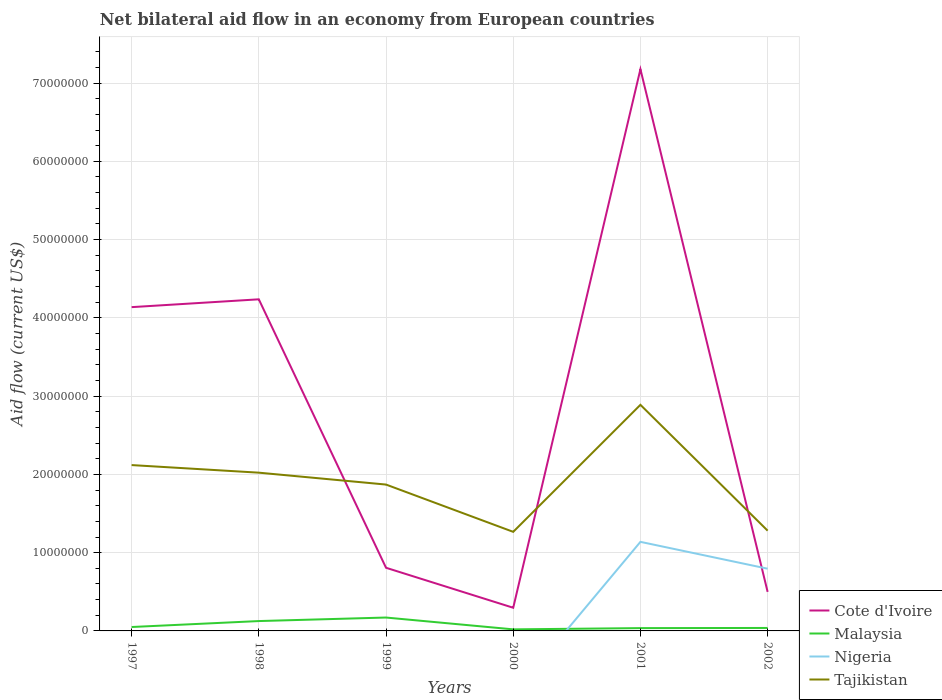Is the number of lines equal to the number of legend labels?
Keep it short and to the point. No. Across all years, what is the maximum net bilateral aid flow in Tajikistan?
Your answer should be compact. 1.27e+07. What is the total net bilateral aid flow in Cote d'Ivoire in the graph?
Provide a succinct answer. -6.88e+07. What is the difference between the highest and the second highest net bilateral aid flow in Malaysia?
Provide a succinct answer. 1.51e+06. How many lines are there?
Your response must be concise. 4. Does the graph contain grids?
Offer a very short reply. Yes. Where does the legend appear in the graph?
Keep it short and to the point. Bottom right. How are the legend labels stacked?
Your response must be concise. Vertical. What is the title of the graph?
Your answer should be very brief. Net bilateral aid flow in an economy from European countries. Does "Guyana" appear as one of the legend labels in the graph?
Provide a succinct answer. No. What is the label or title of the X-axis?
Your answer should be very brief. Years. What is the Aid flow (current US$) in Cote d'Ivoire in 1997?
Your answer should be compact. 4.14e+07. What is the Aid flow (current US$) of Malaysia in 1997?
Make the answer very short. 5.00e+05. What is the Aid flow (current US$) in Tajikistan in 1997?
Your answer should be very brief. 2.12e+07. What is the Aid flow (current US$) in Cote d'Ivoire in 1998?
Give a very brief answer. 4.24e+07. What is the Aid flow (current US$) in Malaysia in 1998?
Make the answer very short. 1.26e+06. What is the Aid flow (current US$) in Nigeria in 1998?
Your response must be concise. 0. What is the Aid flow (current US$) in Tajikistan in 1998?
Offer a very short reply. 2.02e+07. What is the Aid flow (current US$) in Cote d'Ivoire in 1999?
Offer a very short reply. 8.07e+06. What is the Aid flow (current US$) in Malaysia in 1999?
Give a very brief answer. 1.71e+06. What is the Aid flow (current US$) of Nigeria in 1999?
Provide a short and direct response. 0. What is the Aid flow (current US$) of Tajikistan in 1999?
Provide a short and direct response. 1.87e+07. What is the Aid flow (current US$) of Cote d'Ivoire in 2000?
Give a very brief answer. 2.96e+06. What is the Aid flow (current US$) in Nigeria in 2000?
Give a very brief answer. 0. What is the Aid flow (current US$) of Tajikistan in 2000?
Keep it short and to the point. 1.27e+07. What is the Aid flow (current US$) in Cote d'Ivoire in 2001?
Your answer should be compact. 7.18e+07. What is the Aid flow (current US$) in Malaysia in 2001?
Provide a succinct answer. 3.60e+05. What is the Aid flow (current US$) in Nigeria in 2001?
Keep it short and to the point. 1.14e+07. What is the Aid flow (current US$) in Tajikistan in 2001?
Offer a very short reply. 2.89e+07. What is the Aid flow (current US$) of Cote d'Ivoire in 2002?
Give a very brief answer. 4.99e+06. What is the Aid flow (current US$) of Nigeria in 2002?
Make the answer very short. 7.95e+06. What is the Aid flow (current US$) of Tajikistan in 2002?
Your response must be concise. 1.28e+07. Across all years, what is the maximum Aid flow (current US$) in Cote d'Ivoire?
Keep it short and to the point. 7.18e+07. Across all years, what is the maximum Aid flow (current US$) in Malaysia?
Provide a short and direct response. 1.71e+06. Across all years, what is the maximum Aid flow (current US$) in Nigeria?
Make the answer very short. 1.14e+07. Across all years, what is the maximum Aid flow (current US$) in Tajikistan?
Make the answer very short. 2.89e+07. Across all years, what is the minimum Aid flow (current US$) of Cote d'Ivoire?
Your answer should be very brief. 2.96e+06. Across all years, what is the minimum Aid flow (current US$) of Malaysia?
Your response must be concise. 2.00e+05. Across all years, what is the minimum Aid flow (current US$) in Tajikistan?
Your response must be concise. 1.27e+07. What is the total Aid flow (current US$) in Cote d'Ivoire in the graph?
Your answer should be very brief. 1.72e+08. What is the total Aid flow (current US$) in Malaysia in the graph?
Keep it short and to the point. 4.41e+06. What is the total Aid flow (current US$) of Nigeria in the graph?
Offer a terse response. 1.93e+07. What is the total Aid flow (current US$) of Tajikistan in the graph?
Provide a short and direct response. 1.14e+08. What is the difference between the Aid flow (current US$) of Cote d'Ivoire in 1997 and that in 1998?
Give a very brief answer. -1.00e+06. What is the difference between the Aid flow (current US$) in Malaysia in 1997 and that in 1998?
Give a very brief answer. -7.60e+05. What is the difference between the Aid flow (current US$) of Tajikistan in 1997 and that in 1998?
Offer a terse response. 9.70e+05. What is the difference between the Aid flow (current US$) of Cote d'Ivoire in 1997 and that in 1999?
Make the answer very short. 3.33e+07. What is the difference between the Aid flow (current US$) in Malaysia in 1997 and that in 1999?
Your answer should be very brief. -1.21e+06. What is the difference between the Aid flow (current US$) in Tajikistan in 1997 and that in 1999?
Your answer should be compact. 2.49e+06. What is the difference between the Aid flow (current US$) in Cote d'Ivoire in 1997 and that in 2000?
Provide a short and direct response. 3.84e+07. What is the difference between the Aid flow (current US$) in Tajikistan in 1997 and that in 2000?
Offer a very short reply. 8.53e+06. What is the difference between the Aid flow (current US$) of Cote d'Ivoire in 1997 and that in 2001?
Keep it short and to the point. -3.04e+07. What is the difference between the Aid flow (current US$) in Tajikistan in 1997 and that in 2001?
Provide a succinct answer. -7.70e+06. What is the difference between the Aid flow (current US$) of Cote d'Ivoire in 1997 and that in 2002?
Make the answer very short. 3.64e+07. What is the difference between the Aid flow (current US$) of Malaysia in 1997 and that in 2002?
Your answer should be compact. 1.20e+05. What is the difference between the Aid flow (current US$) in Tajikistan in 1997 and that in 2002?
Give a very brief answer. 8.38e+06. What is the difference between the Aid flow (current US$) of Cote d'Ivoire in 1998 and that in 1999?
Your answer should be very brief. 3.43e+07. What is the difference between the Aid flow (current US$) in Malaysia in 1998 and that in 1999?
Ensure brevity in your answer.  -4.50e+05. What is the difference between the Aid flow (current US$) of Tajikistan in 1998 and that in 1999?
Provide a succinct answer. 1.52e+06. What is the difference between the Aid flow (current US$) of Cote d'Ivoire in 1998 and that in 2000?
Your answer should be compact. 3.94e+07. What is the difference between the Aid flow (current US$) in Malaysia in 1998 and that in 2000?
Your answer should be compact. 1.06e+06. What is the difference between the Aid flow (current US$) of Tajikistan in 1998 and that in 2000?
Provide a short and direct response. 7.56e+06. What is the difference between the Aid flow (current US$) in Cote d'Ivoire in 1998 and that in 2001?
Ensure brevity in your answer.  -2.94e+07. What is the difference between the Aid flow (current US$) in Malaysia in 1998 and that in 2001?
Your answer should be very brief. 9.00e+05. What is the difference between the Aid flow (current US$) in Tajikistan in 1998 and that in 2001?
Your answer should be compact. -8.67e+06. What is the difference between the Aid flow (current US$) in Cote d'Ivoire in 1998 and that in 2002?
Make the answer very short. 3.74e+07. What is the difference between the Aid flow (current US$) in Malaysia in 1998 and that in 2002?
Your answer should be compact. 8.80e+05. What is the difference between the Aid flow (current US$) in Tajikistan in 1998 and that in 2002?
Provide a succinct answer. 7.41e+06. What is the difference between the Aid flow (current US$) in Cote d'Ivoire in 1999 and that in 2000?
Your response must be concise. 5.11e+06. What is the difference between the Aid flow (current US$) in Malaysia in 1999 and that in 2000?
Your answer should be very brief. 1.51e+06. What is the difference between the Aid flow (current US$) of Tajikistan in 1999 and that in 2000?
Ensure brevity in your answer.  6.04e+06. What is the difference between the Aid flow (current US$) in Cote d'Ivoire in 1999 and that in 2001?
Your answer should be compact. -6.37e+07. What is the difference between the Aid flow (current US$) in Malaysia in 1999 and that in 2001?
Offer a very short reply. 1.35e+06. What is the difference between the Aid flow (current US$) of Tajikistan in 1999 and that in 2001?
Offer a terse response. -1.02e+07. What is the difference between the Aid flow (current US$) of Cote d'Ivoire in 1999 and that in 2002?
Keep it short and to the point. 3.08e+06. What is the difference between the Aid flow (current US$) of Malaysia in 1999 and that in 2002?
Keep it short and to the point. 1.33e+06. What is the difference between the Aid flow (current US$) of Tajikistan in 1999 and that in 2002?
Make the answer very short. 5.89e+06. What is the difference between the Aid flow (current US$) of Cote d'Ivoire in 2000 and that in 2001?
Offer a very short reply. -6.88e+07. What is the difference between the Aid flow (current US$) in Malaysia in 2000 and that in 2001?
Ensure brevity in your answer.  -1.60e+05. What is the difference between the Aid flow (current US$) in Tajikistan in 2000 and that in 2001?
Your answer should be compact. -1.62e+07. What is the difference between the Aid flow (current US$) of Cote d'Ivoire in 2000 and that in 2002?
Your answer should be compact. -2.03e+06. What is the difference between the Aid flow (current US$) of Tajikistan in 2000 and that in 2002?
Ensure brevity in your answer.  -1.50e+05. What is the difference between the Aid flow (current US$) of Cote d'Ivoire in 2001 and that in 2002?
Keep it short and to the point. 6.68e+07. What is the difference between the Aid flow (current US$) of Nigeria in 2001 and that in 2002?
Offer a terse response. 3.43e+06. What is the difference between the Aid flow (current US$) in Tajikistan in 2001 and that in 2002?
Your answer should be compact. 1.61e+07. What is the difference between the Aid flow (current US$) of Cote d'Ivoire in 1997 and the Aid flow (current US$) of Malaysia in 1998?
Offer a very short reply. 4.01e+07. What is the difference between the Aid flow (current US$) in Cote d'Ivoire in 1997 and the Aid flow (current US$) in Tajikistan in 1998?
Make the answer very short. 2.12e+07. What is the difference between the Aid flow (current US$) of Malaysia in 1997 and the Aid flow (current US$) of Tajikistan in 1998?
Your answer should be compact. -1.97e+07. What is the difference between the Aid flow (current US$) in Cote d'Ivoire in 1997 and the Aid flow (current US$) in Malaysia in 1999?
Offer a terse response. 3.97e+07. What is the difference between the Aid flow (current US$) of Cote d'Ivoire in 1997 and the Aid flow (current US$) of Tajikistan in 1999?
Offer a very short reply. 2.27e+07. What is the difference between the Aid flow (current US$) in Malaysia in 1997 and the Aid flow (current US$) in Tajikistan in 1999?
Your answer should be compact. -1.82e+07. What is the difference between the Aid flow (current US$) of Cote d'Ivoire in 1997 and the Aid flow (current US$) of Malaysia in 2000?
Make the answer very short. 4.12e+07. What is the difference between the Aid flow (current US$) of Cote d'Ivoire in 1997 and the Aid flow (current US$) of Tajikistan in 2000?
Provide a short and direct response. 2.87e+07. What is the difference between the Aid flow (current US$) in Malaysia in 1997 and the Aid flow (current US$) in Tajikistan in 2000?
Keep it short and to the point. -1.22e+07. What is the difference between the Aid flow (current US$) in Cote d'Ivoire in 1997 and the Aid flow (current US$) in Malaysia in 2001?
Ensure brevity in your answer.  4.10e+07. What is the difference between the Aid flow (current US$) in Cote d'Ivoire in 1997 and the Aid flow (current US$) in Nigeria in 2001?
Ensure brevity in your answer.  3.00e+07. What is the difference between the Aid flow (current US$) of Cote d'Ivoire in 1997 and the Aid flow (current US$) of Tajikistan in 2001?
Your response must be concise. 1.25e+07. What is the difference between the Aid flow (current US$) in Malaysia in 1997 and the Aid flow (current US$) in Nigeria in 2001?
Your answer should be very brief. -1.09e+07. What is the difference between the Aid flow (current US$) of Malaysia in 1997 and the Aid flow (current US$) of Tajikistan in 2001?
Give a very brief answer. -2.84e+07. What is the difference between the Aid flow (current US$) in Cote d'Ivoire in 1997 and the Aid flow (current US$) in Malaysia in 2002?
Your answer should be very brief. 4.10e+07. What is the difference between the Aid flow (current US$) in Cote d'Ivoire in 1997 and the Aid flow (current US$) in Nigeria in 2002?
Your response must be concise. 3.34e+07. What is the difference between the Aid flow (current US$) of Cote d'Ivoire in 1997 and the Aid flow (current US$) of Tajikistan in 2002?
Keep it short and to the point. 2.86e+07. What is the difference between the Aid flow (current US$) of Malaysia in 1997 and the Aid flow (current US$) of Nigeria in 2002?
Give a very brief answer. -7.45e+06. What is the difference between the Aid flow (current US$) in Malaysia in 1997 and the Aid flow (current US$) in Tajikistan in 2002?
Provide a short and direct response. -1.23e+07. What is the difference between the Aid flow (current US$) of Cote d'Ivoire in 1998 and the Aid flow (current US$) of Malaysia in 1999?
Provide a succinct answer. 4.07e+07. What is the difference between the Aid flow (current US$) of Cote d'Ivoire in 1998 and the Aid flow (current US$) of Tajikistan in 1999?
Your answer should be very brief. 2.37e+07. What is the difference between the Aid flow (current US$) of Malaysia in 1998 and the Aid flow (current US$) of Tajikistan in 1999?
Give a very brief answer. -1.74e+07. What is the difference between the Aid flow (current US$) of Cote d'Ivoire in 1998 and the Aid flow (current US$) of Malaysia in 2000?
Give a very brief answer. 4.22e+07. What is the difference between the Aid flow (current US$) of Cote d'Ivoire in 1998 and the Aid flow (current US$) of Tajikistan in 2000?
Make the answer very short. 2.97e+07. What is the difference between the Aid flow (current US$) in Malaysia in 1998 and the Aid flow (current US$) in Tajikistan in 2000?
Keep it short and to the point. -1.14e+07. What is the difference between the Aid flow (current US$) of Cote d'Ivoire in 1998 and the Aid flow (current US$) of Malaysia in 2001?
Provide a short and direct response. 4.20e+07. What is the difference between the Aid flow (current US$) in Cote d'Ivoire in 1998 and the Aid flow (current US$) in Nigeria in 2001?
Your response must be concise. 3.10e+07. What is the difference between the Aid flow (current US$) in Cote d'Ivoire in 1998 and the Aid flow (current US$) in Tajikistan in 2001?
Provide a short and direct response. 1.35e+07. What is the difference between the Aid flow (current US$) in Malaysia in 1998 and the Aid flow (current US$) in Nigeria in 2001?
Offer a very short reply. -1.01e+07. What is the difference between the Aid flow (current US$) of Malaysia in 1998 and the Aid flow (current US$) of Tajikistan in 2001?
Provide a succinct answer. -2.76e+07. What is the difference between the Aid flow (current US$) in Cote d'Ivoire in 1998 and the Aid flow (current US$) in Malaysia in 2002?
Give a very brief answer. 4.20e+07. What is the difference between the Aid flow (current US$) in Cote d'Ivoire in 1998 and the Aid flow (current US$) in Nigeria in 2002?
Give a very brief answer. 3.44e+07. What is the difference between the Aid flow (current US$) of Cote d'Ivoire in 1998 and the Aid flow (current US$) of Tajikistan in 2002?
Give a very brief answer. 2.96e+07. What is the difference between the Aid flow (current US$) of Malaysia in 1998 and the Aid flow (current US$) of Nigeria in 2002?
Ensure brevity in your answer.  -6.69e+06. What is the difference between the Aid flow (current US$) of Malaysia in 1998 and the Aid flow (current US$) of Tajikistan in 2002?
Keep it short and to the point. -1.16e+07. What is the difference between the Aid flow (current US$) in Cote d'Ivoire in 1999 and the Aid flow (current US$) in Malaysia in 2000?
Make the answer very short. 7.87e+06. What is the difference between the Aid flow (current US$) of Cote d'Ivoire in 1999 and the Aid flow (current US$) of Tajikistan in 2000?
Your answer should be very brief. -4.59e+06. What is the difference between the Aid flow (current US$) of Malaysia in 1999 and the Aid flow (current US$) of Tajikistan in 2000?
Provide a short and direct response. -1.10e+07. What is the difference between the Aid flow (current US$) of Cote d'Ivoire in 1999 and the Aid flow (current US$) of Malaysia in 2001?
Give a very brief answer. 7.71e+06. What is the difference between the Aid flow (current US$) of Cote d'Ivoire in 1999 and the Aid flow (current US$) of Nigeria in 2001?
Provide a succinct answer. -3.31e+06. What is the difference between the Aid flow (current US$) of Cote d'Ivoire in 1999 and the Aid flow (current US$) of Tajikistan in 2001?
Make the answer very short. -2.08e+07. What is the difference between the Aid flow (current US$) in Malaysia in 1999 and the Aid flow (current US$) in Nigeria in 2001?
Offer a terse response. -9.67e+06. What is the difference between the Aid flow (current US$) of Malaysia in 1999 and the Aid flow (current US$) of Tajikistan in 2001?
Make the answer very short. -2.72e+07. What is the difference between the Aid flow (current US$) of Cote d'Ivoire in 1999 and the Aid flow (current US$) of Malaysia in 2002?
Your answer should be very brief. 7.69e+06. What is the difference between the Aid flow (current US$) of Cote d'Ivoire in 1999 and the Aid flow (current US$) of Tajikistan in 2002?
Provide a succinct answer. -4.74e+06. What is the difference between the Aid flow (current US$) in Malaysia in 1999 and the Aid flow (current US$) in Nigeria in 2002?
Your answer should be very brief. -6.24e+06. What is the difference between the Aid flow (current US$) in Malaysia in 1999 and the Aid flow (current US$) in Tajikistan in 2002?
Give a very brief answer. -1.11e+07. What is the difference between the Aid flow (current US$) in Cote d'Ivoire in 2000 and the Aid flow (current US$) in Malaysia in 2001?
Your answer should be compact. 2.60e+06. What is the difference between the Aid flow (current US$) of Cote d'Ivoire in 2000 and the Aid flow (current US$) of Nigeria in 2001?
Your response must be concise. -8.42e+06. What is the difference between the Aid flow (current US$) in Cote d'Ivoire in 2000 and the Aid flow (current US$) in Tajikistan in 2001?
Offer a very short reply. -2.59e+07. What is the difference between the Aid flow (current US$) of Malaysia in 2000 and the Aid flow (current US$) of Nigeria in 2001?
Offer a terse response. -1.12e+07. What is the difference between the Aid flow (current US$) in Malaysia in 2000 and the Aid flow (current US$) in Tajikistan in 2001?
Your answer should be compact. -2.87e+07. What is the difference between the Aid flow (current US$) in Cote d'Ivoire in 2000 and the Aid flow (current US$) in Malaysia in 2002?
Provide a short and direct response. 2.58e+06. What is the difference between the Aid flow (current US$) of Cote d'Ivoire in 2000 and the Aid flow (current US$) of Nigeria in 2002?
Provide a short and direct response. -4.99e+06. What is the difference between the Aid flow (current US$) of Cote d'Ivoire in 2000 and the Aid flow (current US$) of Tajikistan in 2002?
Provide a short and direct response. -9.85e+06. What is the difference between the Aid flow (current US$) of Malaysia in 2000 and the Aid flow (current US$) of Nigeria in 2002?
Offer a very short reply. -7.75e+06. What is the difference between the Aid flow (current US$) in Malaysia in 2000 and the Aid flow (current US$) in Tajikistan in 2002?
Provide a short and direct response. -1.26e+07. What is the difference between the Aid flow (current US$) in Cote d'Ivoire in 2001 and the Aid flow (current US$) in Malaysia in 2002?
Provide a short and direct response. 7.14e+07. What is the difference between the Aid flow (current US$) of Cote d'Ivoire in 2001 and the Aid flow (current US$) of Nigeria in 2002?
Your answer should be very brief. 6.38e+07. What is the difference between the Aid flow (current US$) of Cote d'Ivoire in 2001 and the Aid flow (current US$) of Tajikistan in 2002?
Your response must be concise. 5.90e+07. What is the difference between the Aid flow (current US$) of Malaysia in 2001 and the Aid flow (current US$) of Nigeria in 2002?
Ensure brevity in your answer.  -7.59e+06. What is the difference between the Aid flow (current US$) of Malaysia in 2001 and the Aid flow (current US$) of Tajikistan in 2002?
Your answer should be compact. -1.24e+07. What is the difference between the Aid flow (current US$) of Nigeria in 2001 and the Aid flow (current US$) of Tajikistan in 2002?
Keep it short and to the point. -1.43e+06. What is the average Aid flow (current US$) in Cote d'Ivoire per year?
Make the answer very short. 2.86e+07. What is the average Aid flow (current US$) in Malaysia per year?
Keep it short and to the point. 7.35e+05. What is the average Aid flow (current US$) in Nigeria per year?
Give a very brief answer. 3.22e+06. What is the average Aid flow (current US$) in Tajikistan per year?
Offer a terse response. 1.91e+07. In the year 1997, what is the difference between the Aid flow (current US$) in Cote d'Ivoire and Aid flow (current US$) in Malaysia?
Provide a succinct answer. 4.09e+07. In the year 1997, what is the difference between the Aid flow (current US$) in Cote d'Ivoire and Aid flow (current US$) in Tajikistan?
Give a very brief answer. 2.02e+07. In the year 1997, what is the difference between the Aid flow (current US$) of Malaysia and Aid flow (current US$) of Tajikistan?
Provide a succinct answer. -2.07e+07. In the year 1998, what is the difference between the Aid flow (current US$) of Cote d'Ivoire and Aid flow (current US$) of Malaysia?
Ensure brevity in your answer.  4.11e+07. In the year 1998, what is the difference between the Aid flow (current US$) in Cote d'Ivoire and Aid flow (current US$) in Tajikistan?
Offer a very short reply. 2.22e+07. In the year 1998, what is the difference between the Aid flow (current US$) in Malaysia and Aid flow (current US$) in Tajikistan?
Your response must be concise. -1.90e+07. In the year 1999, what is the difference between the Aid flow (current US$) in Cote d'Ivoire and Aid flow (current US$) in Malaysia?
Ensure brevity in your answer.  6.36e+06. In the year 1999, what is the difference between the Aid flow (current US$) of Cote d'Ivoire and Aid flow (current US$) of Tajikistan?
Provide a short and direct response. -1.06e+07. In the year 1999, what is the difference between the Aid flow (current US$) in Malaysia and Aid flow (current US$) in Tajikistan?
Give a very brief answer. -1.70e+07. In the year 2000, what is the difference between the Aid flow (current US$) of Cote d'Ivoire and Aid flow (current US$) of Malaysia?
Keep it short and to the point. 2.76e+06. In the year 2000, what is the difference between the Aid flow (current US$) of Cote d'Ivoire and Aid flow (current US$) of Tajikistan?
Ensure brevity in your answer.  -9.70e+06. In the year 2000, what is the difference between the Aid flow (current US$) in Malaysia and Aid flow (current US$) in Tajikistan?
Your answer should be very brief. -1.25e+07. In the year 2001, what is the difference between the Aid flow (current US$) of Cote d'Ivoire and Aid flow (current US$) of Malaysia?
Provide a succinct answer. 7.14e+07. In the year 2001, what is the difference between the Aid flow (current US$) in Cote d'Ivoire and Aid flow (current US$) in Nigeria?
Offer a very short reply. 6.04e+07. In the year 2001, what is the difference between the Aid flow (current US$) of Cote d'Ivoire and Aid flow (current US$) of Tajikistan?
Your answer should be compact. 4.29e+07. In the year 2001, what is the difference between the Aid flow (current US$) of Malaysia and Aid flow (current US$) of Nigeria?
Make the answer very short. -1.10e+07. In the year 2001, what is the difference between the Aid flow (current US$) of Malaysia and Aid flow (current US$) of Tajikistan?
Your answer should be very brief. -2.85e+07. In the year 2001, what is the difference between the Aid flow (current US$) in Nigeria and Aid flow (current US$) in Tajikistan?
Make the answer very short. -1.75e+07. In the year 2002, what is the difference between the Aid flow (current US$) of Cote d'Ivoire and Aid flow (current US$) of Malaysia?
Keep it short and to the point. 4.61e+06. In the year 2002, what is the difference between the Aid flow (current US$) of Cote d'Ivoire and Aid flow (current US$) of Nigeria?
Your response must be concise. -2.96e+06. In the year 2002, what is the difference between the Aid flow (current US$) of Cote d'Ivoire and Aid flow (current US$) of Tajikistan?
Keep it short and to the point. -7.82e+06. In the year 2002, what is the difference between the Aid flow (current US$) of Malaysia and Aid flow (current US$) of Nigeria?
Provide a succinct answer. -7.57e+06. In the year 2002, what is the difference between the Aid flow (current US$) in Malaysia and Aid flow (current US$) in Tajikistan?
Make the answer very short. -1.24e+07. In the year 2002, what is the difference between the Aid flow (current US$) of Nigeria and Aid flow (current US$) of Tajikistan?
Your response must be concise. -4.86e+06. What is the ratio of the Aid flow (current US$) of Cote d'Ivoire in 1997 to that in 1998?
Offer a very short reply. 0.98. What is the ratio of the Aid flow (current US$) of Malaysia in 1997 to that in 1998?
Ensure brevity in your answer.  0.4. What is the ratio of the Aid flow (current US$) in Tajikistan in 1997 to that in 1998?
Offer a very short reply. 1.05. What is the ratio of the Aid flow (current US$) in Cote d'Ivoire in 1997 to that in 1999?
Make the answer very short. 5.13. What is the ratio of the Aid flow (current US$) in Malaysia in 1997 to that in 1999?
Your answer should be very brief. 0.29. What is the ratio of the Aid flow (current US$) in Tajikistan in 1997 to that in 1999?
Provide a short and direct response. 1.13. What is the ratio of the Aid flow (current US$) of Cote d'Ivoire in 1997 to that in 2000?
Offer a terse response. 13.98. What is the ratio of the Aid flow (current US$) of Tajikistan in 1997 to that in 2000?
Keep it short and to the point. 1.67. What is the ratio of the Aid flow (current US$) of Cote d'Ivoire in 1997 to that in 2001?
Make the answer very short. 0.58. What is the ratio of the Aid flow (current US$) in Malaysia in 1997 to that in 2001?
Provide a short and direct response. 1.39. What is the ratio of the Aid flow (current US$) in Tajikistan in 1997 to that in 2001?
Your answer should be compact. 0.73. What is the ratio of the Aid flow (current US$) of Cote d'Ivoire in 1997 to that in 2002?
Your response must be concise. 8.29. What is the ratio of the Aid flow (current US$) in Malaysia in 1997 to that in 2002?
Give a very brief answer. 1.32. What is the ratio of the Aid flow (current US$) in Tajikistan in 1997 to that in 2002?
Give a very brief answer. 1.65. What is the ratio of the Aid flow (current US$) of Cote d'Ivoire in 1998 to that in 1999?
Your answer should be very brief. 5.25. What is the ratio of the Aid flow (current US$) in Malaysia in 1998 to that in 1999?
Your answer should be compact. 0.74. What is the ratio of the Aid flow (current US$) of Tajikistan in 1998 to that in 1999?
Offer a terse response. 1.08. What is the ratio of the Aid flow (current US$) in Cote d'Ivoire in 1998 to that in 2000?
Keep it short and to the point. 14.31. What is the ratio of the Aid flow (current US$) of Tajikistan in 1998 to that in 2000?
Offer a terse response. 1.6. What is the ratio of the Aid flow (current US$) of Cote d'Ivoire in 1998 to that in 2001?
Your response must be concise. 0.59. What is the ratio of the Aid flow (current US$) of Malaysia in 1998 to that in 2001?
Your answer should be compact. 3.5. What is the ratio of the Aid flow (current US$) in Tajikistan in 1998 to that in 2001?
Your response must be concise. 0.7. What is the ratio of the Aid flow (current US$) of Cote d'Ivoire in 1998 to that in 2002?
Ensure brevity in your answer.  8.49. What is the ratio of the Aid flow (current US$) of Malaysia in 1998 to that in 2002?
Offer a very short reply. 3.32. What is the ratio of the Aid flow (current US$) in Tajikistan in 1998 to that in 2002?
Provide a short and direct response. 1.58. What is the ratio of the Aid flow (current US$) of Cote d'Ivoire in 1999 to that in 2000?
Make the answer very short. 2.73. What is the ratio of the Aid flow (current US$) of Malaysia in 1999 to that in 2000?
Provide a short and direct response. 8.55. What is the ratio of the Aid flow (current US$) of Tajikistan in 1999 to that in 2000?
Offer a terse response. 1.48. What is the ratio of the Aid flow (current US$) of Cote d'Ivoire in 1999 to that in 2001?
Keep it short and to the point. 0.11. What is the ratio of the Aid flow (current US$) of Malaysia in 1999 to that in 2001?
Keep it short and to the point. 4.75. What is the ratio of the Aid flow (current US$) of Tajikistan in 1999 to that in 2001?
Ensure brevity in your answer.  0.65. What is the ratio of the Aid flow (current US$) of Cote d'Ivoire in 1999 to that in 2002?
Keep it short and to the point. 1.62. What is the ratio of the Aid flow (current US$) of Tajikistan in 1999 to that in 2002?
Your answer should be very brief. 1.46. What is the ratio of the Aid flow (current US$) of Cote d'Ivoire in 2000 to that in 2001?
Make the answer very short. 0.04. What is the ratio of the Aid flow (current US$) of Malaysia in 2000 to that in 2001?
Make the answer very short. 0.56. What is the ratio of the Aid flow (current US$) of Tajikistan in 2000 to that in 2001?
Your answer should be compact. 0.44. What is the ratio of the Aid flow (current US$) in Cote d'Ivoire in 2000 to that in 2002?
Your answer should be compact. 0.59. What is the ratio of the Aid flow (current US$) of Malaysia in 2000 to that in 2002?
Your response must be concise. 0.53. What is the ratio of the Aid flow (current US$) in Tajikistan in 2000 to that in 2002?
Provide a short and direct response. 0.99. What is the ratio of the Aid flow (current US$) of Cote d'Ivoire in 2001 to that in 2002?
Provide a succinct answer. 14.38. What is the ratio of the Aid flow (current US$) in Malaysia in 2001 to that in 2002?
Give a very brief answer. 0.95. What is the ratio of the Aid flow (current US$) of Nigeria in 2001 to that in 2002?
Provide a succinct answer. 1.43. What is the ratio of the Aid flow (current US$) of Tajikistan in 2001 to that in 2002?
Provide a succinct answer. 2.26. What is the difference between the highest and the second highest Aid flow (current US$) of Cote d'Ivoire?
Offer a terse response. 2.94e+07. What is the difference between the highest and the second highest Aid flow (current US$) of Tajikistan?
Offer a terse response. 7.70e+06. What is the difference between the highest and the lowest Aid flow (current US$) of Cote d'Ivoire?
Give a very brief answer. 6.88e+07. What is the difference between the highest and the lowest Aid flow (current US$) in Malaysia?
Your response must be concise. 1.51e+06. What is the difference between the highest and the lowest Aid flow (current US$) of Nigeria?
Give a very brief answer. 1.14e+07. What is the difference between the highest and the lowest Aid flow (current US$) in Tajikistan?
Your answer should be very brief. 1.62e+07. 